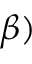<formula> <loc_0><loc_0><loc_500><loc_500>\beta )</formula> 